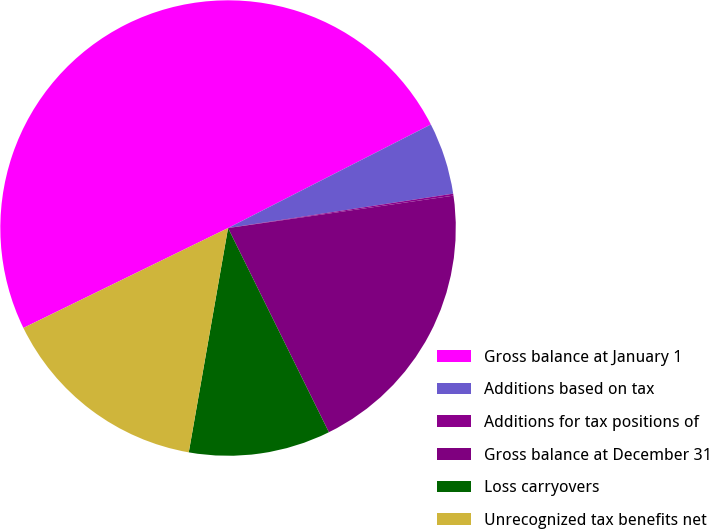<chart> <loc_0><loc_0><loc_500><loc_500><pie_chart><fcel>Gross balance at January 1<fcel>Additions based on tax<fcel>Additions for tax positions of<fcel>Gross balance at December 31<fcel>Loss carryovers<fcel>Unrecognized tax benefits net<nl><fcel>49.71%<fcel>5.1%<fcel>0.14%<fcel>19.97%<fcel>10.06%<fcel>15.01%<nl></chart> 